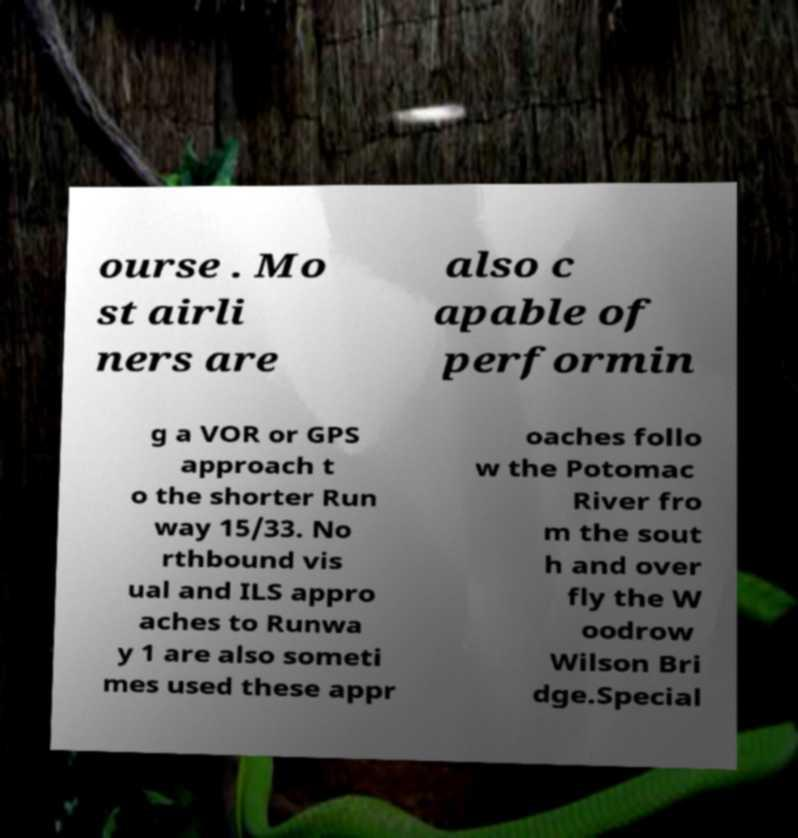I need the written content from this picture converted into text. Can you do that? ourse . Mo st airli ners are also c apable of performin g a VOR or GPS approach t o the shorter Run way 15/33. No rthbound vis ual and ILS appro aches to Runwa y 1 are also someti mes used these appr oaches follo w the Potomac River fro m the sout h and over fly the W oodrow Wilson Bri dge.Special 